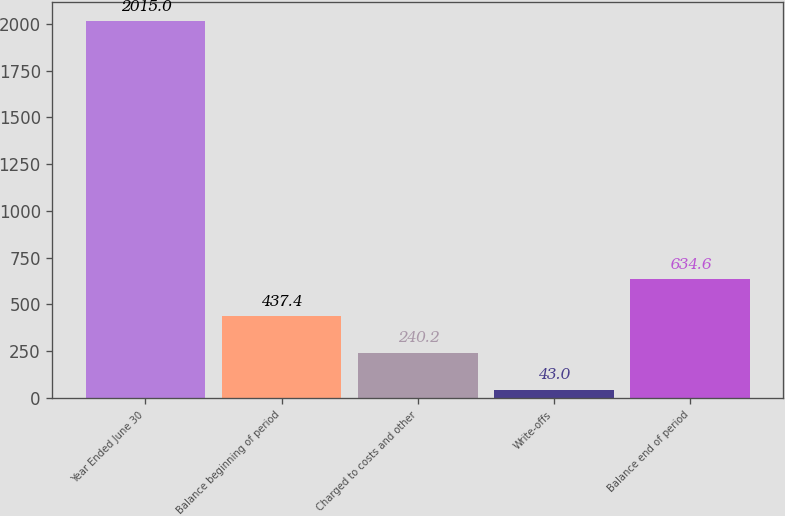Convert chart to OTSL. <chart><loc_0><loc_0><loc_500><loc_500><bar_chart><fcel>Year Ended June 30<fcel>Balance beginning of period<fcel>Charged to costs and other<fcel>Write-offs<fcel>Balance end of period<nl><fcel>2015<fcel>437.4<fcel>240.2<fcel>43<fcel>634.6<nl></chart> 